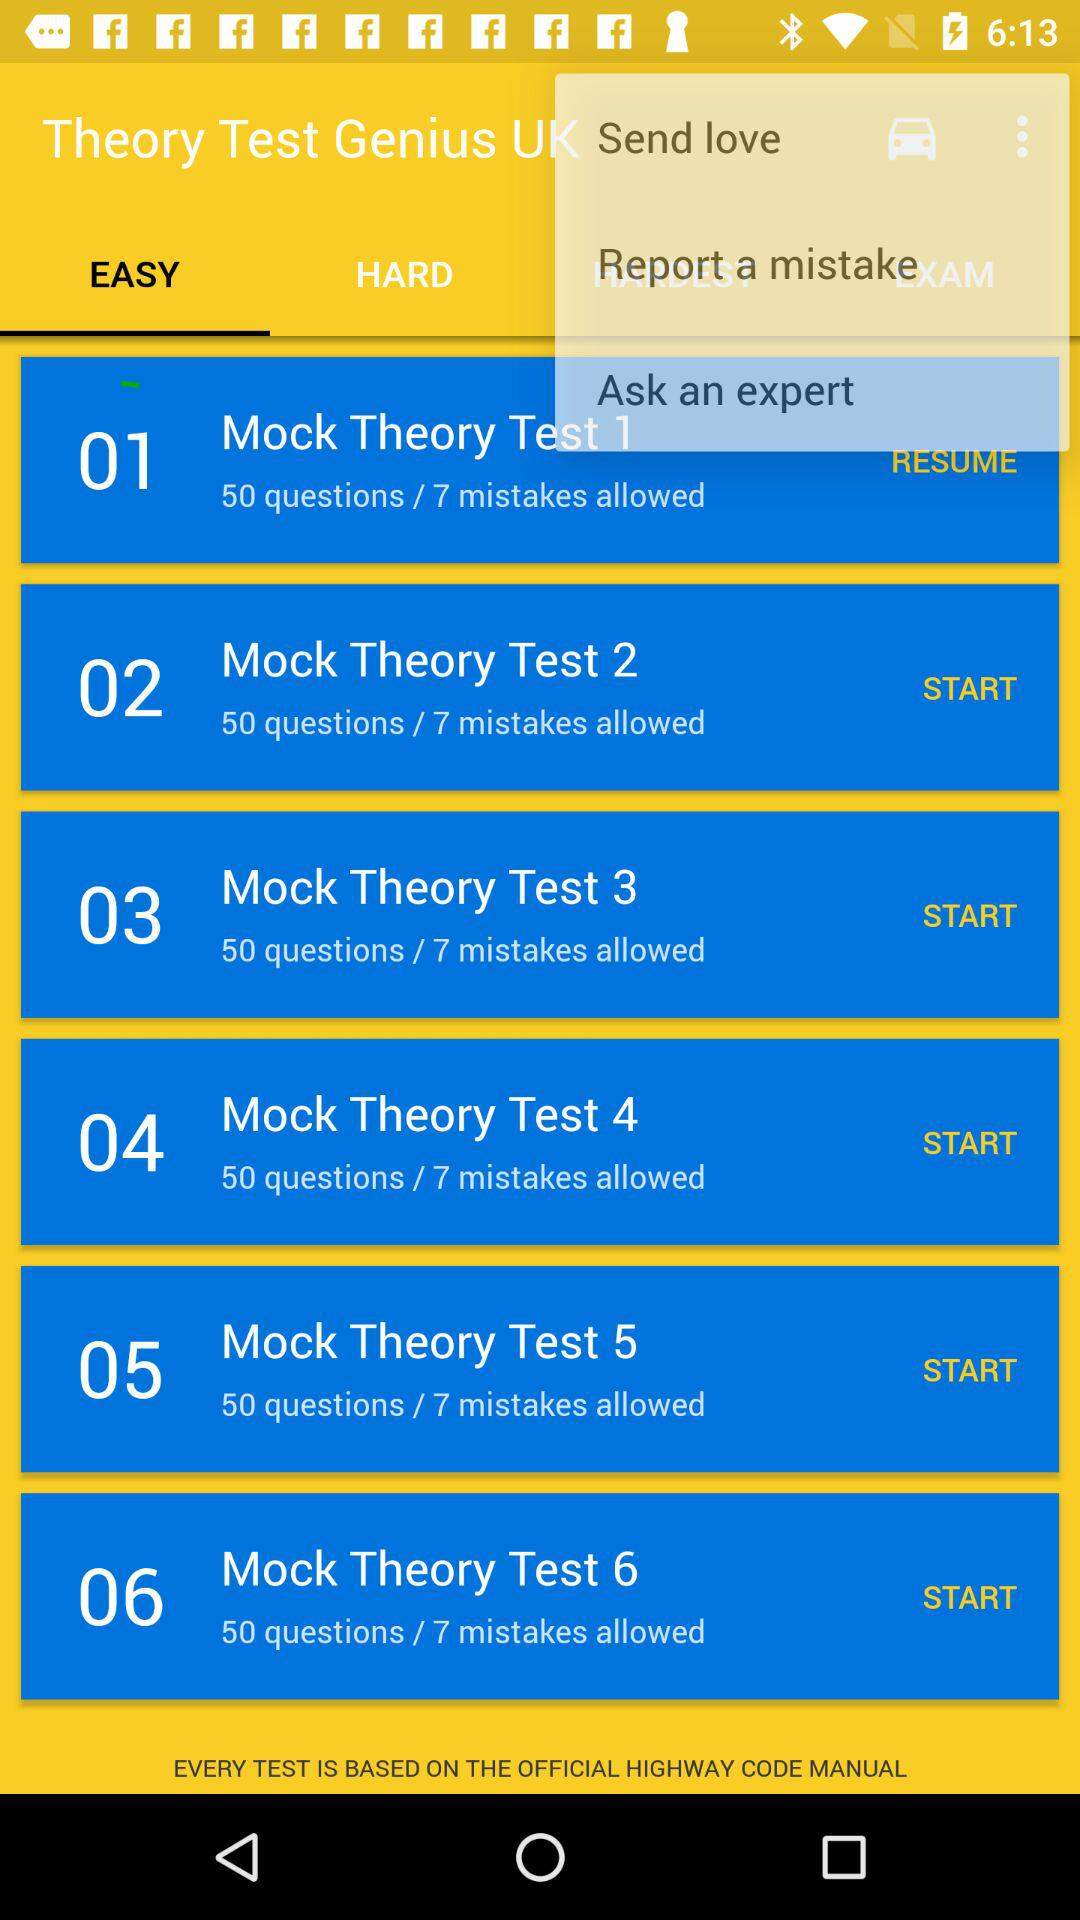How many tests are there in total?
Answer the question using a single word or phrase. 6 